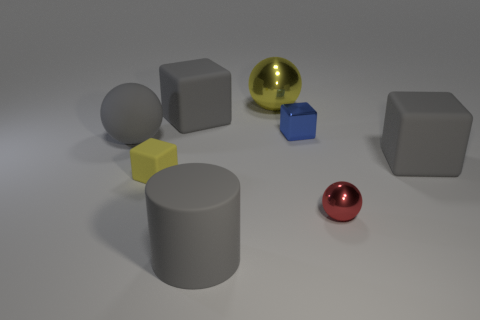Add 1 large cubes. How many objects exist? 9 Subtract all cylinders. How many objects are left? 7 Add 2 large shiny objects. How many large shiny objects exist? 3 Subtract 0 brown cylinders. How many objects are left? 8 Subtract all small green rubber spheres. Subtract all blue shiny objects. How many objects are left? 7 Add 2 tiny red spheres. How many tiny red spheres are left? 3 